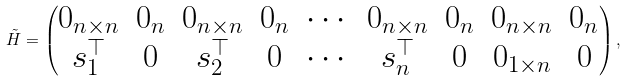<formula> <loc_0><loc_0><loc_500><loc_500>\tilde { H } = \begin{pmatrix} 0 _ { n \times n } & 0 _ { n } & 0 _ { n \times n } & 0 _ { n } & \cdots & 0 _ { n \times n } & 0 _ { n } & 0 _ { n \times n } & 0 _ { n } \\ s _ { 1 } ^ { \top } & 0 & s _ { 2 } ^ { \top } & 0 & \cdots & s _ { n } ^ { \top } & 0 & 0 _ { 1 \times n } & 0 \\ \end{pmatrix} ,</formula> 